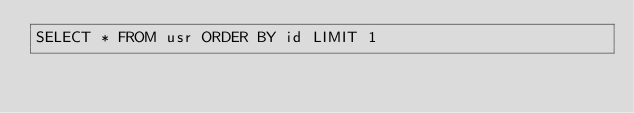Convert code to text. <code><loc_0><loc_0><loc_500><loc_500><_SQL_>SELECT * FROM usr ORDER BY id LIMIT 1</code> 